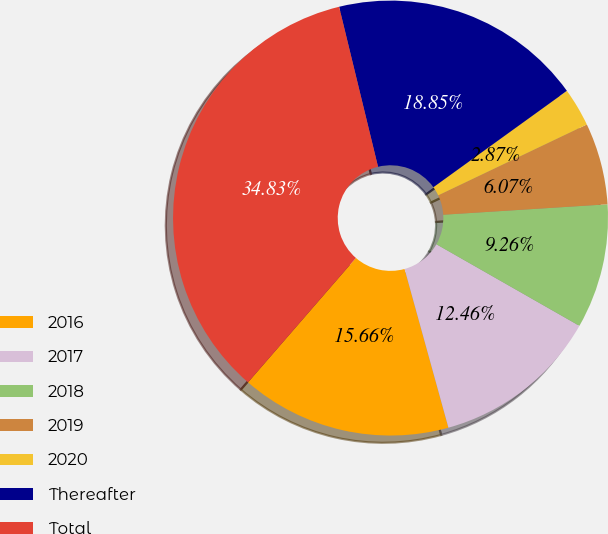Convert chart to OTSL. <chart><loc_0><loc_0><loc_500><loc_500><pie_chart><fcel>2016<fcel>2017<fcel>2018<fcel>2019<fcel>2020<fcel>Thereafter<fcel>Total<nl><fcel>15.66%<fcel>12.46%<fcel>9.26%<fcel>6.07%<fcel>2.87%<fcel>18.85%<fcel>34.83%<nl></chart> 